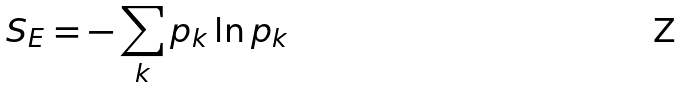Convert formula to latex. <formula><loc_0><loc_0><loc_500><loc_500>S _ { E } = - \sum _ { k } p _ { k } \ln p _ { k }</formula> 